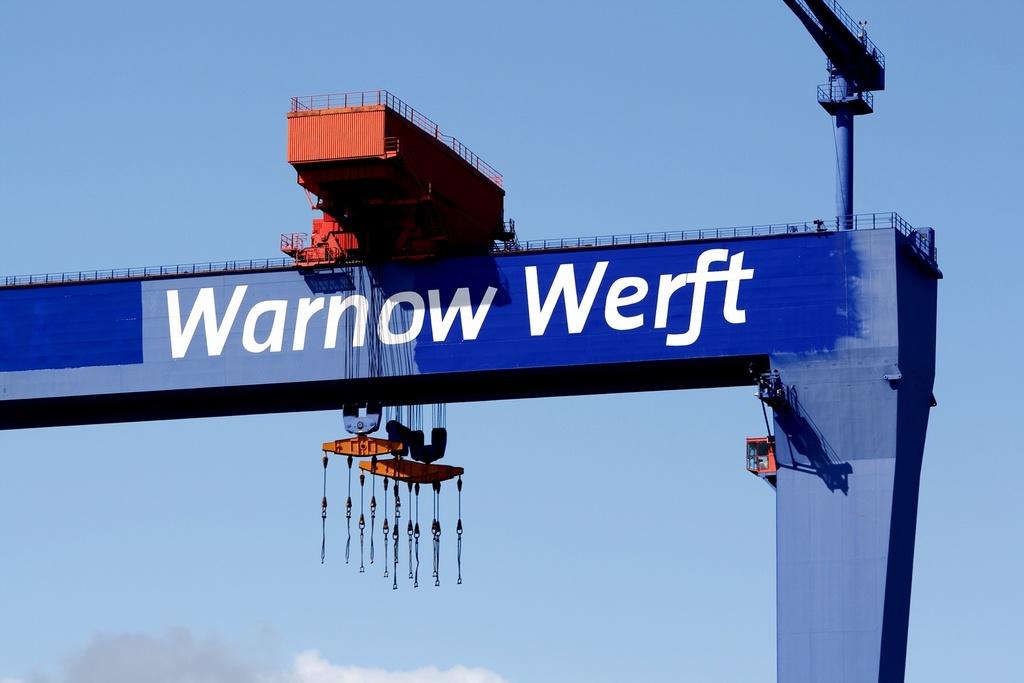What does this say?
Your answer should be very brief. Warnow werft. 